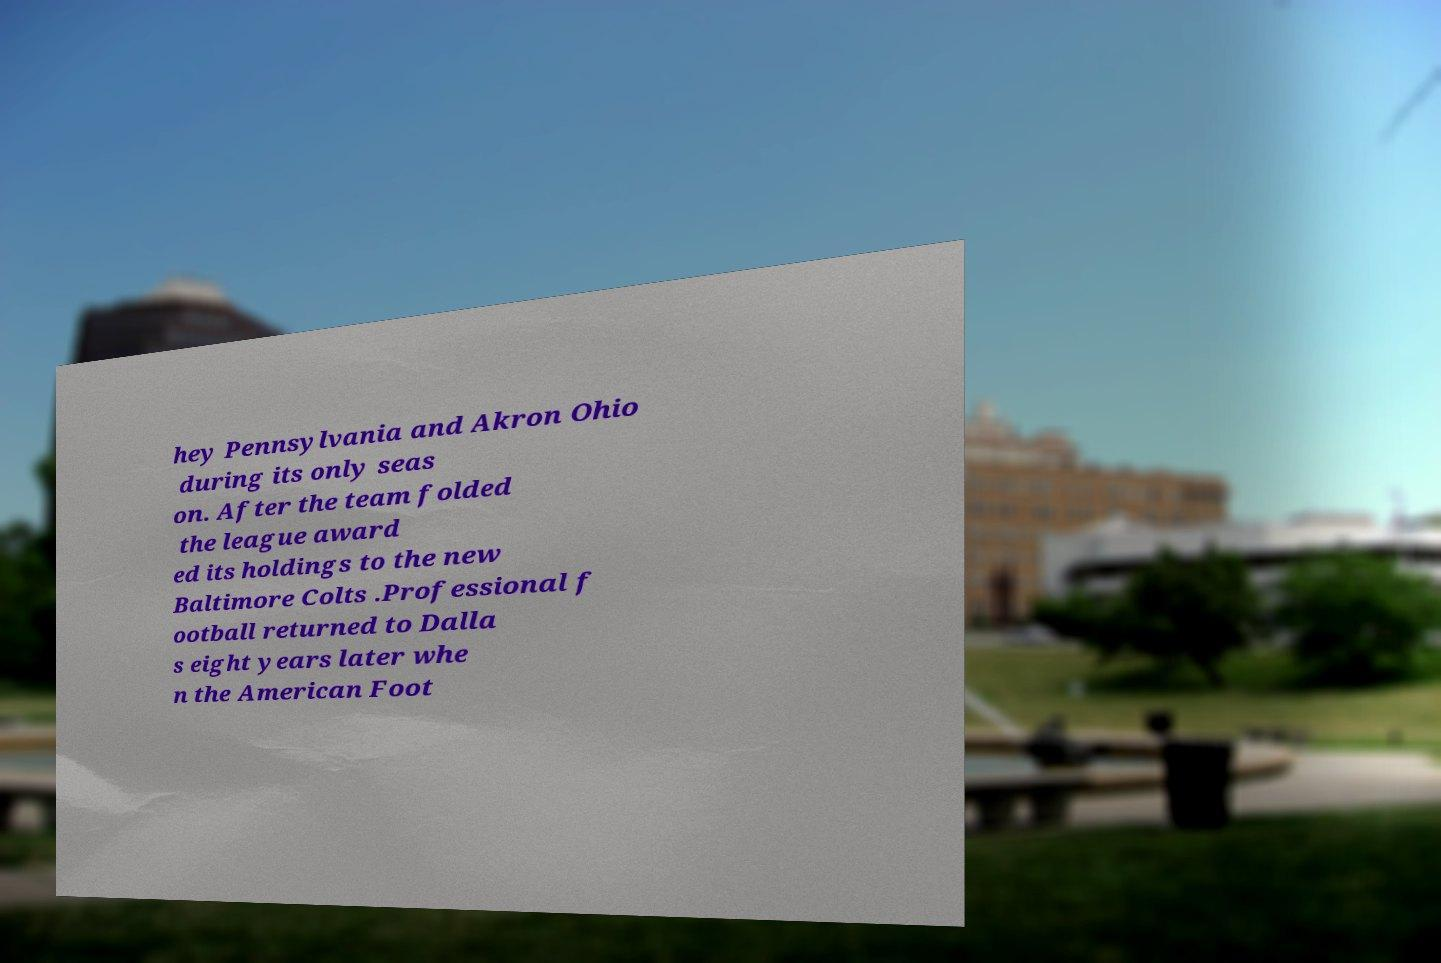Can you accurately transcribe the text from the provided image for me? hey Pennsylvania and Akron Ohio during its only seas on. After the team folded the league award ed its holdings to the new Baltimore Colts .Professional f ootball returned to Dalla s eight years later whe n the American Foot 